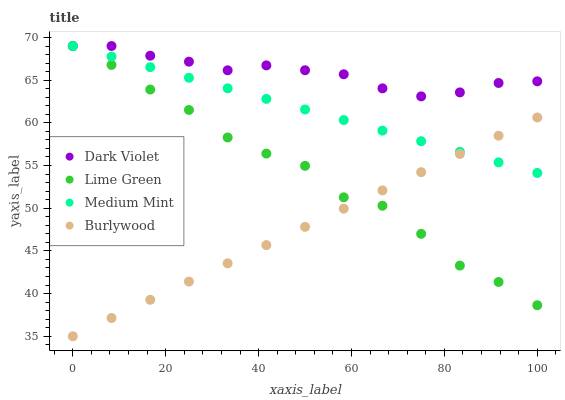Does Burlywood have the minimum area under the curve?
Answer yes or no. Yes. Does Dark Violet have the maximum area under the curve?
Answer yes or no. Yes. Does Lime Green have the minimum area under the curve?
Answer yes or no. No. Does Lime Green have the maximum area under the curve?
Answer yes or no. No. Is Burlywood the smoothest?
Answer yes or no. Yes. Is Lime Green the roughest?
Answer yes or no. Yes. Is Lime Green the smoothest?
Answer yes or no. No. Is Burlywood the roughest?
Answer yes or no. No. Does Burlywood have the lowest value?
Answer yes or no. Yes. Does Lime Green have the lowest value?
Answer yes or no. No. Does Dark Violet have the highest value?
Answer yes or no. Yes. Does Burlywood have the highest value?
Answer yes or no. No. Is Burlywood less than Dark Violet?
Answer yes or no. Yes. Is Dark Violet greater than Burlywood?
Answer yes or no. Yes. Does Lime Green intersect Medium Mint?
Answer yes or no. Yes. Is Lime Green less than Medium Mint?
Answer yes or no. No. Is Lime Green greater than Medium Mint?
Answer yes or no. No. Does Burlywood intersect Dark Violet?
Answer yes or no. No. 